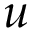Convert formula to latex. <formula><loc_0><loc_0><loc_500><loc_500>u</formula> 